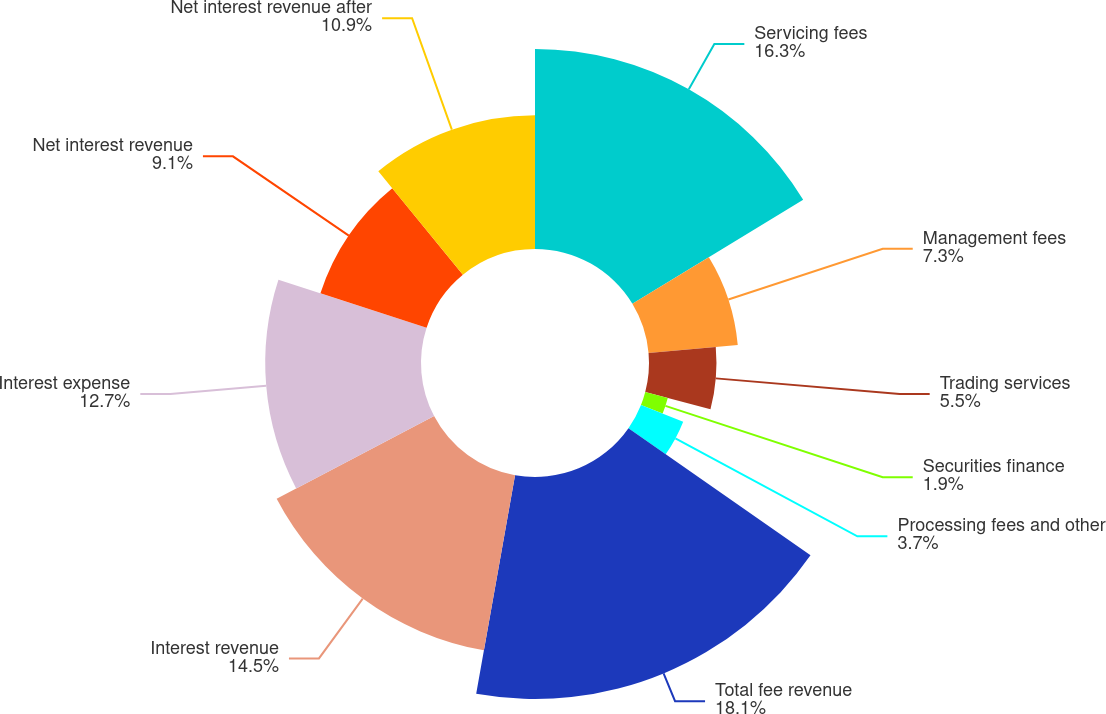<chart> <loc_0><loc_0><loc_500><loc_500><pie_chart><fcel>Servicing fees<fcel>Management fees<fcel>Trading services<fcel>Securities finance<fcel>Processing fees and other<fcel>Total fee revenue<fcel>Interest revenue<fcel>Interest expense<fcel>Net interest revenue<fcel>Net interest revenue after<nl><fcel>16.3%<fcel>7.3%<fcel>5.5%<fcel>1.9%<fcel>3.7%<fcel>18.1%<fcel>14.5%<fcel>12.7%<fcel>9.1%<fcel>10.9%<nl></chart> 